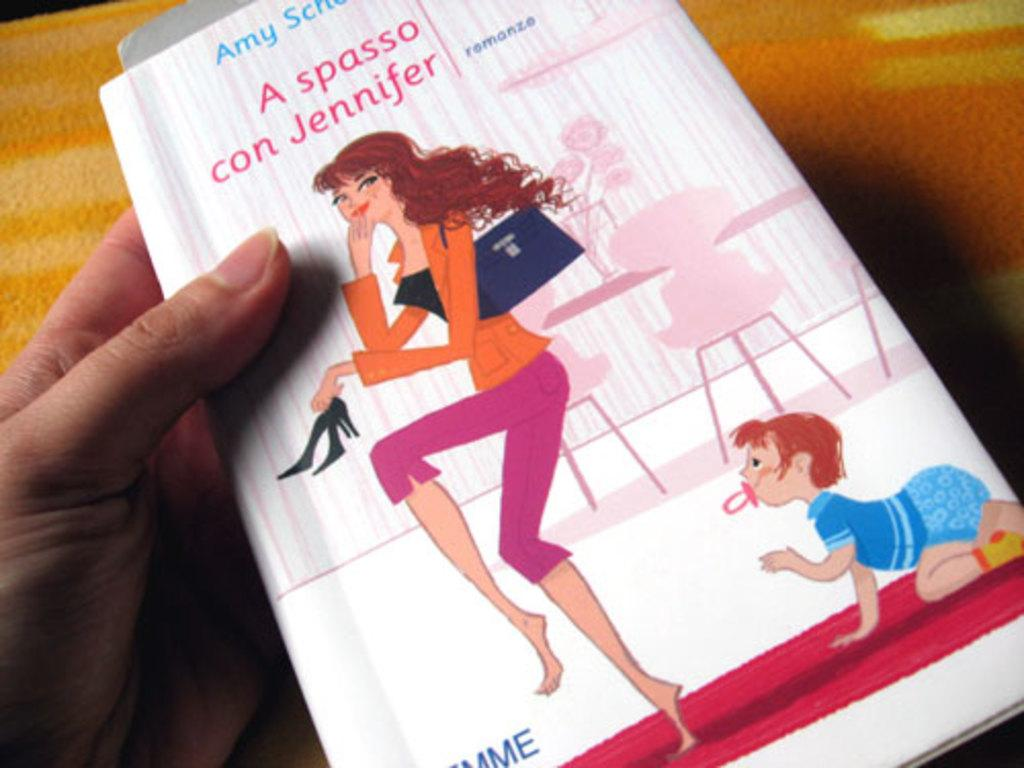What is the person's hand holding in the image? There is a person's hand holding a book in the image. What can be seen at the bottom of the image? There is a cloth at the bottom of the image. What type of curve can be seen in the person's brain in the image? There is no person's brain visible in the image, only a hand holding a book and a cloth at the bottom. 